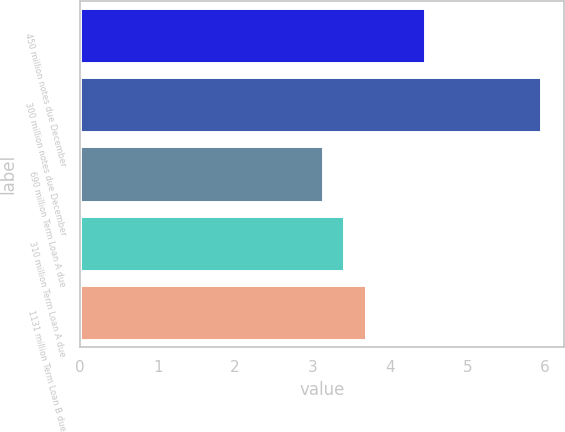Convert chart to OTSL. <chart><loc_0><loc_0><loc_500><loc_500><bar_chart><fcel>450 million notes due December<fcel>300 million notes due December<fcel>690 million Term Loan A due<fcel>310 million Term Loan A due<fcel>1131 million Term Loan B due<nl><fcel>4.45<fcel>5.95<fcel>3.13<fcel>3.41<fcel>3.69<nl></chart> 